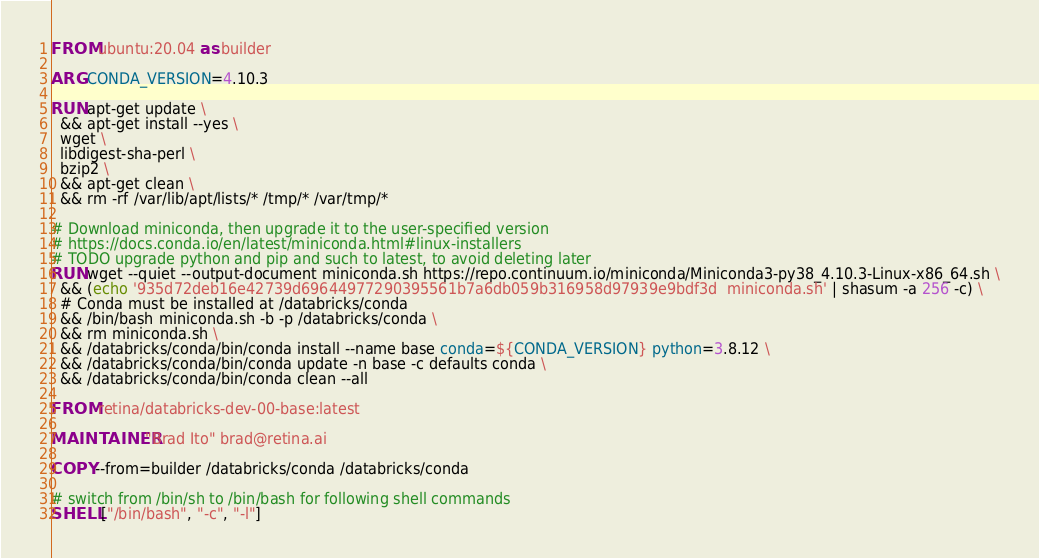Convert code to text. <code><loc_0><loc_0><loc_500><loc_500><_Dockerfile_>FROM ubuntu:20.04 as builder

ARG CONDA_VERSION=4.10.3

RUN apt-get update \
  && apt-get install --yes \
  wget \
  libdigest-sha-perl \
  bzip2 \
  && apt-get clean \
  && rm -rf /var/lib/apt/lists/* /tmp/* /var/tmp/*

# Download miniconda, then upgrade it to the user-specified version
# https://docs.conda.io/en/latest/miniconda.html#linux-installers
# TODO upgrade python and pip and such to latest, to avoid deleting later
RUN wget --quiet --output-document miniconda.sh https://repo.continuum.io/miniconda/Miniconda3-py38_4.10.3-Linux-x86_64.sh \
  && (echo '935d72deb16e42739d69644977290395561b7a6db059b316958d97939e9bdf3d  miniconda.sh' | shasum -a 256 -c) \
  # Conda must be installed at /databricks/conda
  && /bin/bash miniconda.sh -b -p /databricks/conda \
  && rm miniconda.sh \
  && /databricks/conda/bin/conda install --name base conda=${CONDA_VERSION} python=3.8.12 \
  && /databricks/conda/bin/conda update -n base -c defaults conda \
  && /databricks/conda/bin/conda clean --all

FROM retina/databricks-dev-00-base:latest

MAINTAINER "Brad Ito" brad@retina.ai

COPY --from=builder /databricks/conda /databricks/conda

# switch from /bin/sh to /bin/bash for following shell commands
SHELL ["/bin/bash", "-c", "-l"]
</code> 